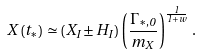Convert formula to latex. <formula><loc_0><loc_0><loc_500><loc_500>X \left ( t _ { * } \right ) \simeq \left ( X _ { I } \pm H _ { I } \right ) \left ( \frac { \Gamma _ { * , 0 } } { m _ { X } } \right ) ^ { \frac { 1 } { 1 + w } } \, .</formula> 